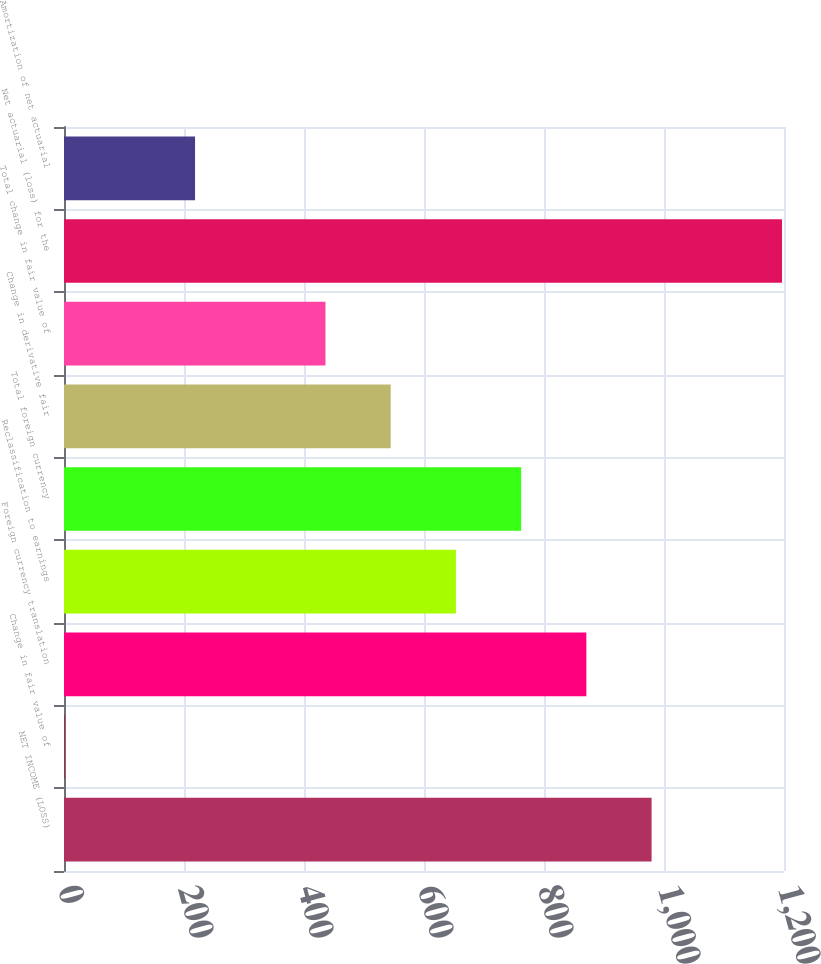Convert chart. <chart><loc_0><loc_0><loc_500><loc_500><bar_chart><fcel>NET INCOME (LOSS)<fcel>Change in fair value of<fcel>Foreign currency translation<fcel>Reclassification to earnings<fcel>Total foreign currency<fcel>Change in derivative fair<fcel>Total change in fair value of<fcel>Net actuarial (loss) for the<fcel>Amortization of net actuarial<nl><fcel>979.3<fcel>1<fcel>870.6<fcel>653.2<fcel>761.9<fcel>544.5<fcel>435.8<fcel>1196.7<fcel>218.4<nl></chart> 